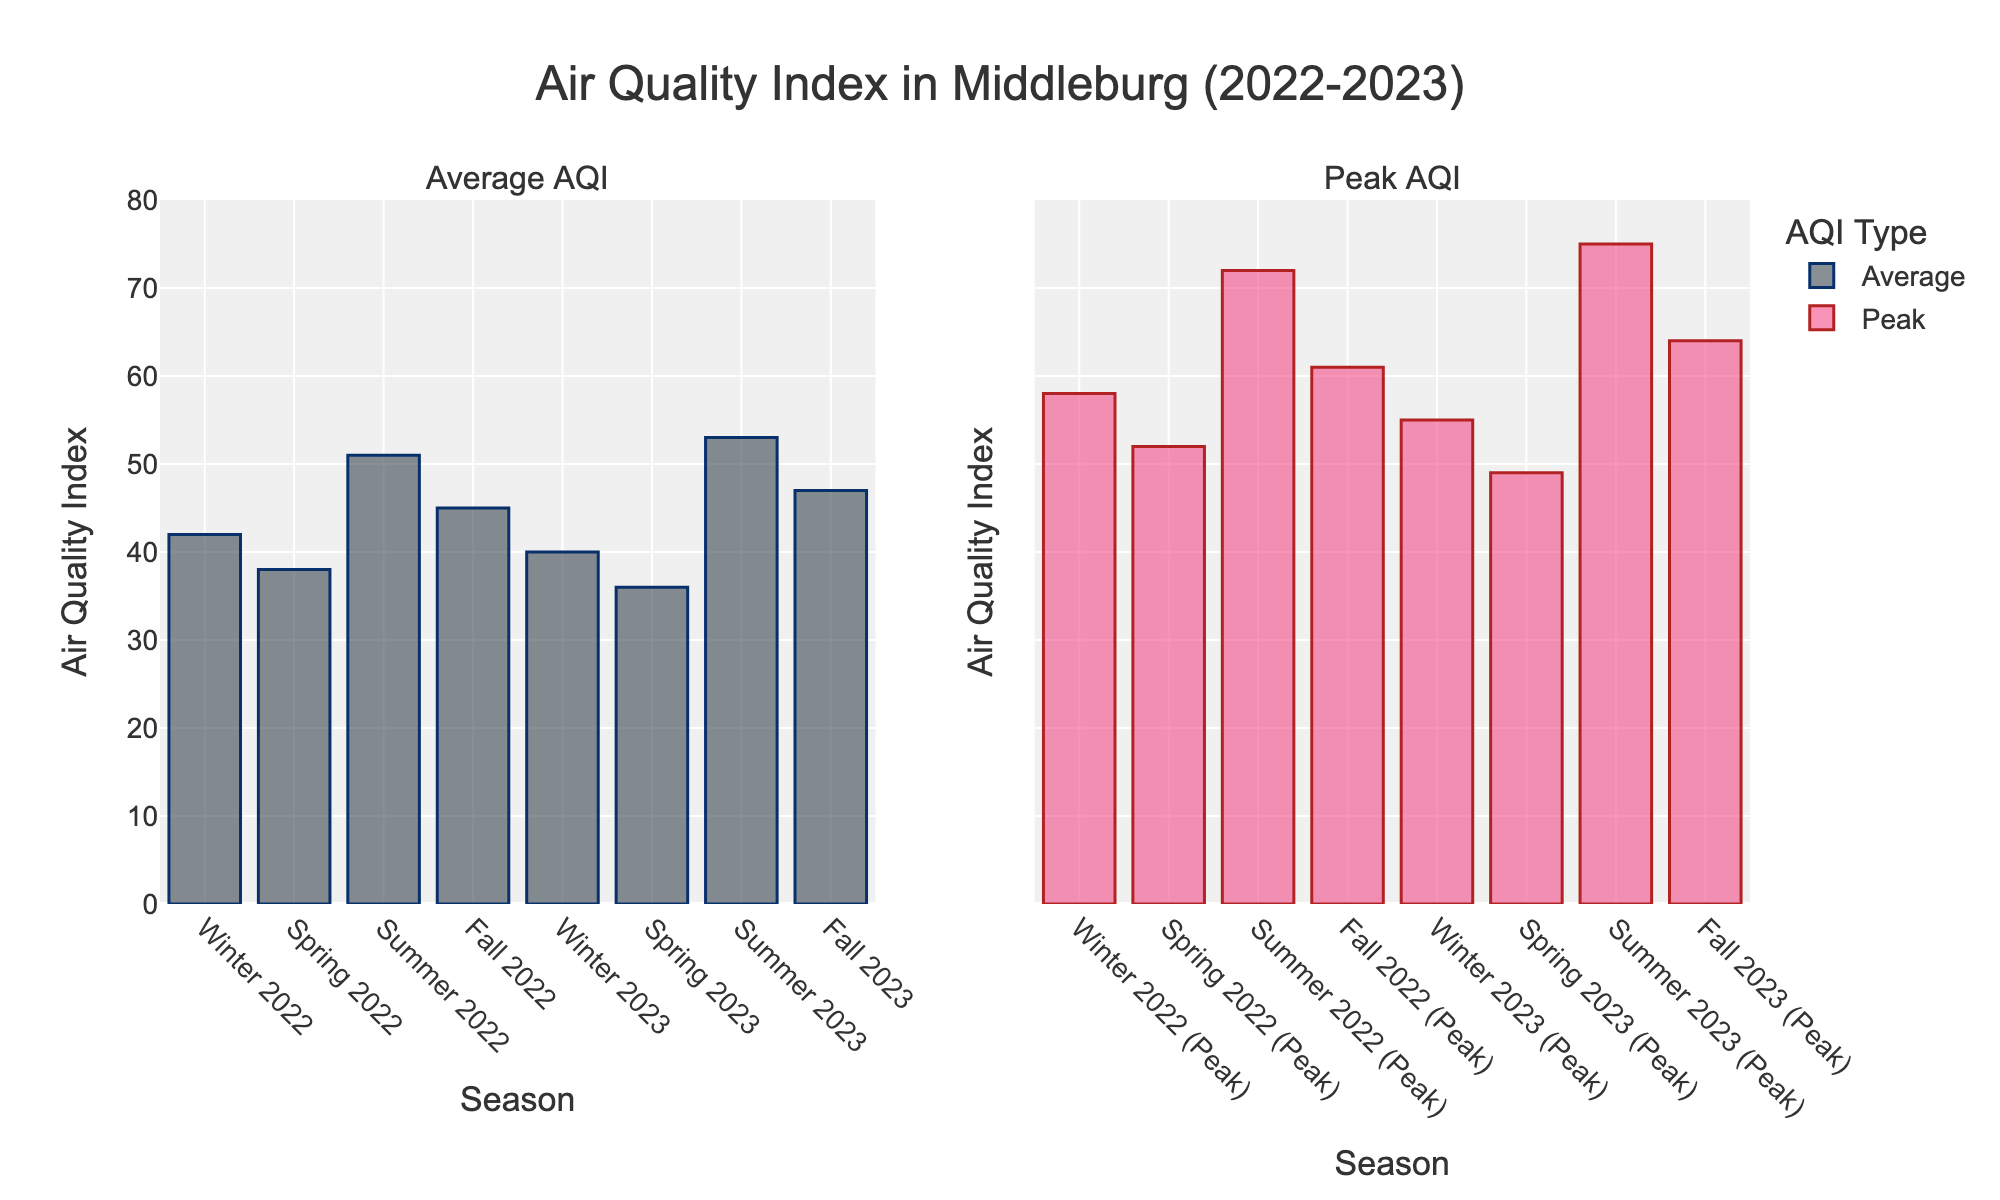What was the average AQI in Summer 2022? Look at the average AQI bar for Summer 2022 in the first subplot. It shows a value of 51.
Answer: 51 Which season had the highest peak AQI in 2023? Compare the heights of the peak AQI bars for each 2023 season in the second subplot. Summer 2023 has the tallest bar, showing a value of 75.
Answer: Summer 2023 How did the average AQI in Fall 2022 compare to the average AQI in Fall 2023? Check the average AQI bars for Fall 2022 and Fall 2023 in the first subplot. Fall 2022 is 45 and Fall 2023 is 47. So, Fall 2023 had a higher average AQI.
Answer: Fall 2023 had a higher average AQI What is the difference between the peak AQI and the average AQI in Winter 2023? Subtract the average AQI for Winter 2023 from the peak AQI for Winter 2023. Peak AQI is 55 and average AQI is 40. So, 55 - 40 = 15.
Answer: 15 Which season experienced the greatest increase in peak AQI from 2022 to 2023? Compare the increase in peak AQI values for each season from 2022 to 2023. Summer shows an increase from 72 to 75, which is 3. Fall shows an increase from 61 to 64, which is 3. Winter shows a decrease and Spring shows a decrease, so neither of them. Both Summer and Fall showed the greatest increase of 3.
Answer: Summer and Fall Did the average AQI improve or worsen from Winter 2022 to Winter 2023? Compare the average AQI bars for Winter 2022 and Winter 2023 in the first subplot. Winter 2022 is 42 and Winter 2023 is 40. So, the average AQI improved.
Answer: Improved What is the overall trend of peak AQI values from Winter 2022 to Fall 2023? Observe the peak AQI bars from Winter 2022 to Fall 2023 in the second subplot. Notice the general pattern of heights. Winter 2022 to Winter 2023 decreased from 58 to 55, Spring 2022 to Spring 2023 decreased from 52 to 49, but Summer 2022 to Summer 2023 increased from 72 to 75, and Fall 2022 to Fall 2023 increased from 61 to 64. Thus, there's no consistent trend.
Answer: No consistent trend Which season shows the smallest difference between its average AQI and peak AQI in both years? Look at both subplots and calculate the difference between average and peak AQI for each season. Winter 2022: 58-42=16, Winter 2023: 55-40=15; Spring 2022: 52-38=14, Spring 2023: 49-36=13; Summer 2022: 72-51=21, Summer 2023: 75-53=22; Fall 2022: 61-45=16, Fall 2023: 64-47=17. Spring has the smallest differences of 14 (2022) and 13 (2023).
Answer: Spring 